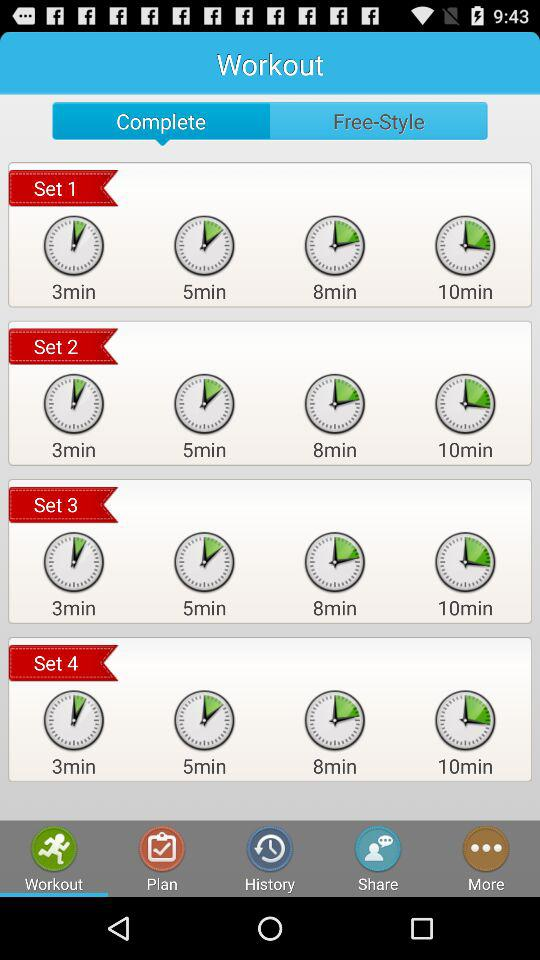Which applications are available for sharing?
When the provided information is insufficient, respond with <no answer>. <no answer> 